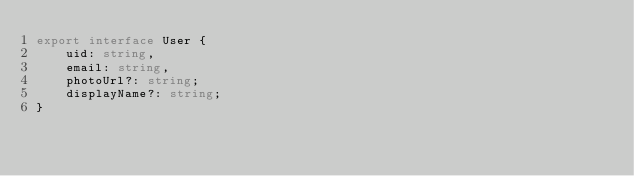<code> <loc_0><loc_0><loc_500><loc_500><_TypeScript_>export interface User {
    uid: string,
    email: string,
    photoUrl?: string;
    displayName?: string;
}</code> 